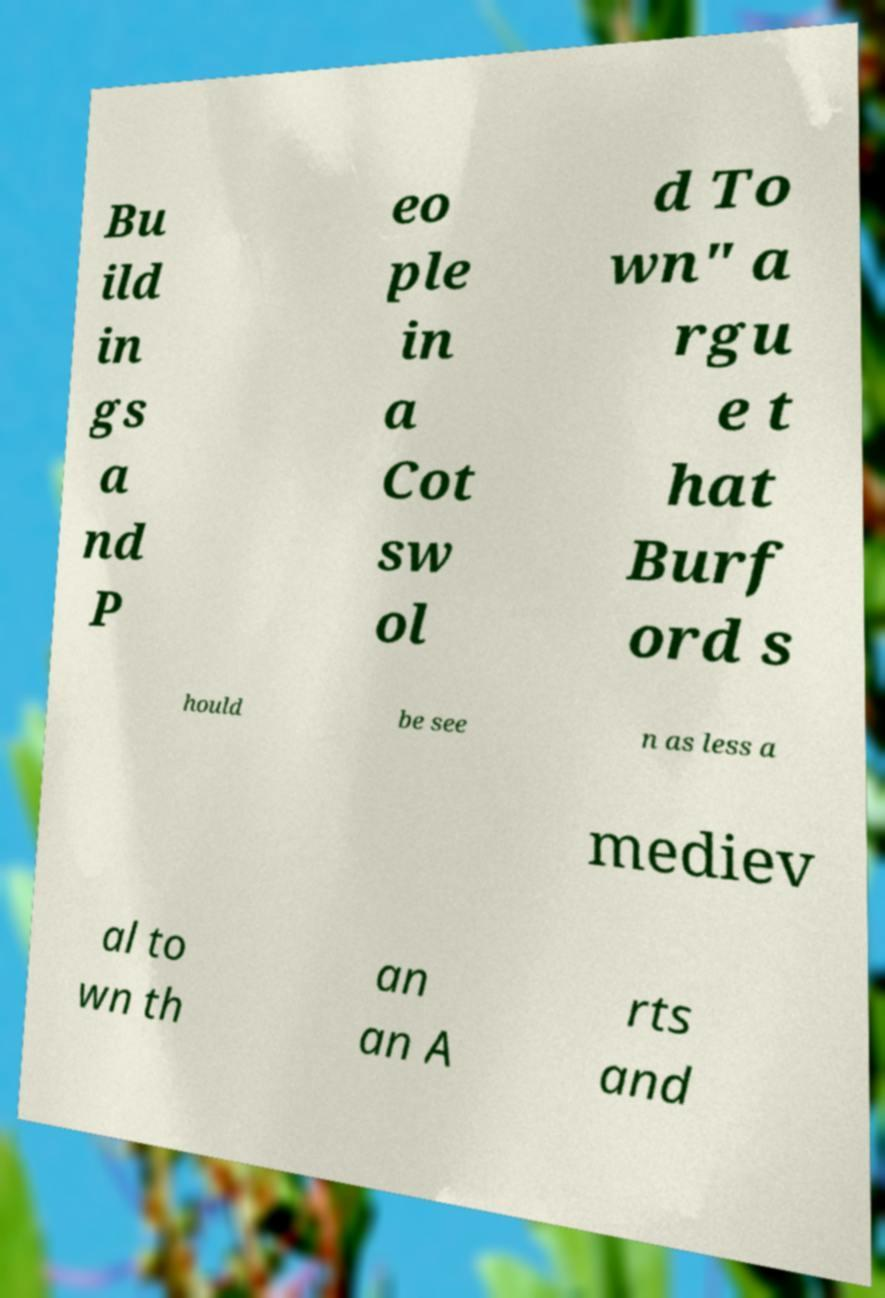Could you extract and type out the text from this image? Bu ild in gs a nd P eo ple in a Cot sw ol d To wn" a rgu e t hat Burf ord s hould be see n as less a mediev al to wn th an an A rts and 